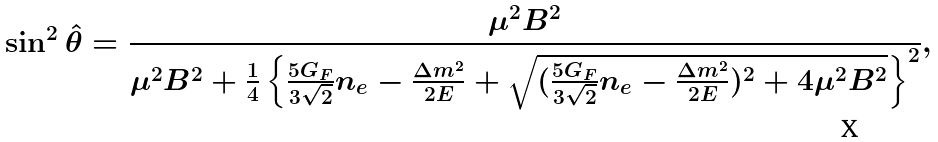<formula> <loc_0><loc_0><loc_500><loc_500>\sin ^ { 2 } { \hat { \theta } } = \frac { \mu ^ { 2 } B ^ { 2 } } { \mu ^ { 2 } B ^ { 2 } + \frac { 1 } { 4 } \left \{ \frac { 5 G _ { F } } { 3 \sqrt { 2 } } n _ { e } - \frac { \Delta m ^ { 2 } } { 2 E } + \sqrt { ( \frac { 5 G _ { F } } { 3 \sqrt { 2 } } n _ { e } - \frac { \Delta m ^ { 2 } } { 2 E } ) ^ { 2 } + 4 \mu ^ { 2 } B ^ { 2 } } \right \} ^ { 2 } } ,</formula> 